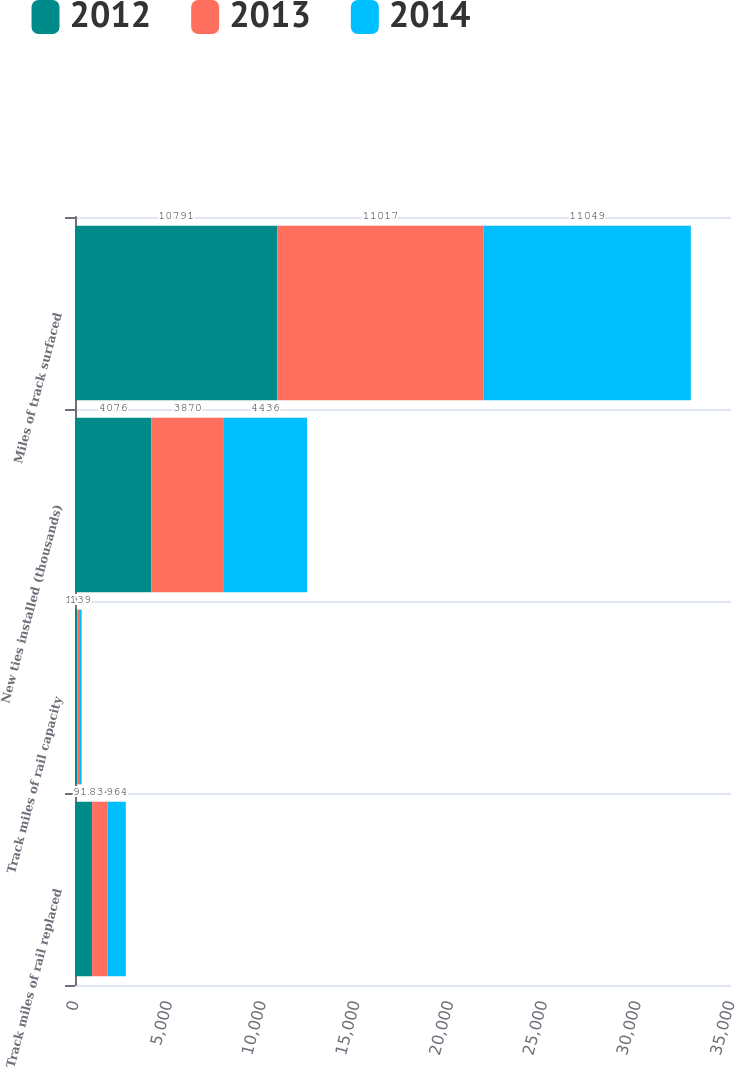<chart> <loc_0><loc_0><loc_500><loc_500><stacked_bar_chart><ecel><fcel>Track miles of rail replaced<fcel>Track miles of rail capacity<fcel>New ties installed (thousands)<fcel>Miles of track surfaced<nl><fcel>2012<fcel>912<fcel>119<fcel>4076<fcel>10791<nl><fcel>2013<fcel>834<fcel>97<fcel>3870<fcel>11017<nl><fcel>2014<fcel>964<fcel>139<fcel>4436<fcel>11049<nl></chart> 